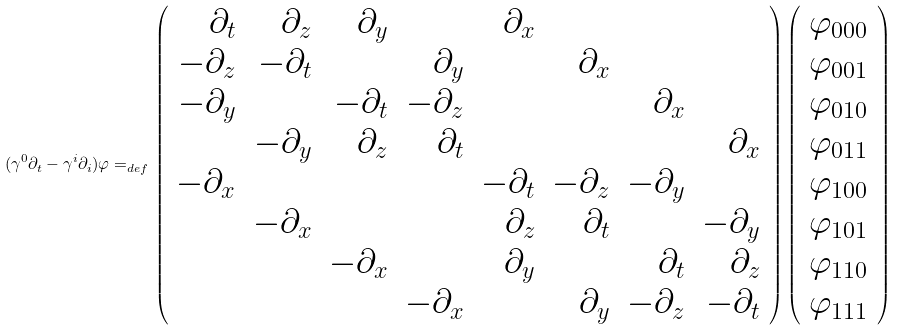<formula> <loc_0><loc_0><loc_500><loc_500>( \gamma ^ { 0 } \partial _ { t } - \gamma ^ { i } \partial _ { i } ) \varphi = _ { d e f } \left ( \begin{array} { r r r r r r r r } \partial _ { t } & \partial _ { z } & \partial _ { y } & & \partial _ { x } & & & \\ - \partial _ { z } & - \partial _ { t } & & \partial _ { y } & & \partial _ { x } & & \\ - \partial _ { y } & & - \partial _ { t } & - \partial _ { z } & & & \partial _ { x } & \\ & - \partial _ { y } & \partial _ { z } & \partial _ { t } & & & & \partial _ { x } \\ - \partial _ { x } & & & & - \partial _ { t } & - \partial _ { z } & - \partial _ { y } & \\ & - \partial _ { x } & & & \partial _ { z } & \partial _ { t } & & - \partial _ { y } \\ & & - \partial _ { x } & & \partial _ { y } & & \partial _ { t } & \partial _ { z } \\ & & & - \partial _ { x } & & \partial _ { y } & - \partial _ { z } & - \partial _ { t } \end{array} \right ) \left ( \begin{array} { r } \varphi _ { 0 0 0 } \\ \varphi _ { 0 0 1 } \\ \varphi _ { 0 1 0 } \\ \varphi _ { 0 1 1 } \\ \varphi _ { 1 0 0 } \\ \varphi _ { 1 0 1 } \\ \varphi _ { 1 1 0 } \\ \varphi _ { 1 1 1 } \end{array} \right )</formula> 